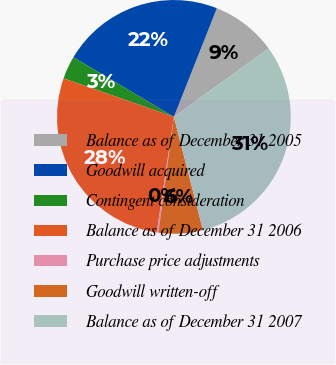Convert chart to OTSL. <chart><loc_0><loc_0><loc_500><loc_500><pie_chart><fcel>Balance as of December 31 2005<fcel>Goodwill acquired<fcel>Contingent consideration<fcel>Balance as of December 31 2006<fcel>Purchase price adjustments<fcel>Goodwill written-off<fcel>Balance as of December 31 2007<nl><fcel>9.05%<fcel>22.47%<fcel>3.17%<fcel>28.01%<fcel>0.23%<fcel>6.11%<fcel>30.96%<nl></chart> 